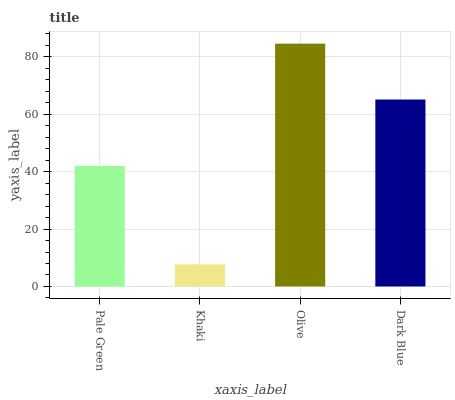Is Khaki the minimum?
Answer yes or no. Yes. Is Olive the maximum?
Answer yes or no. Yes. Is Olive the minimum?
Answer yes or no. No. Is Khaki the maximum?
Answer yes or no. No. Is Olive greater than Khaki?
Answer yes or no. Yes. Is Khaki less than Olive?
Answer yes or no. Yes. Is Khaki greater than Olive?
Answer yes or no. No. Is Olive less than Khaki?
Answer yes or no. No. Is Dark Blue the high median?
Answer yes or no. Yes. Is Pale Green the low median?
Answer yes or no. Yes. Is Pale Green the high median?
Answer yes or no. No. Is Olive the low median?
Answer yes or no. No. 